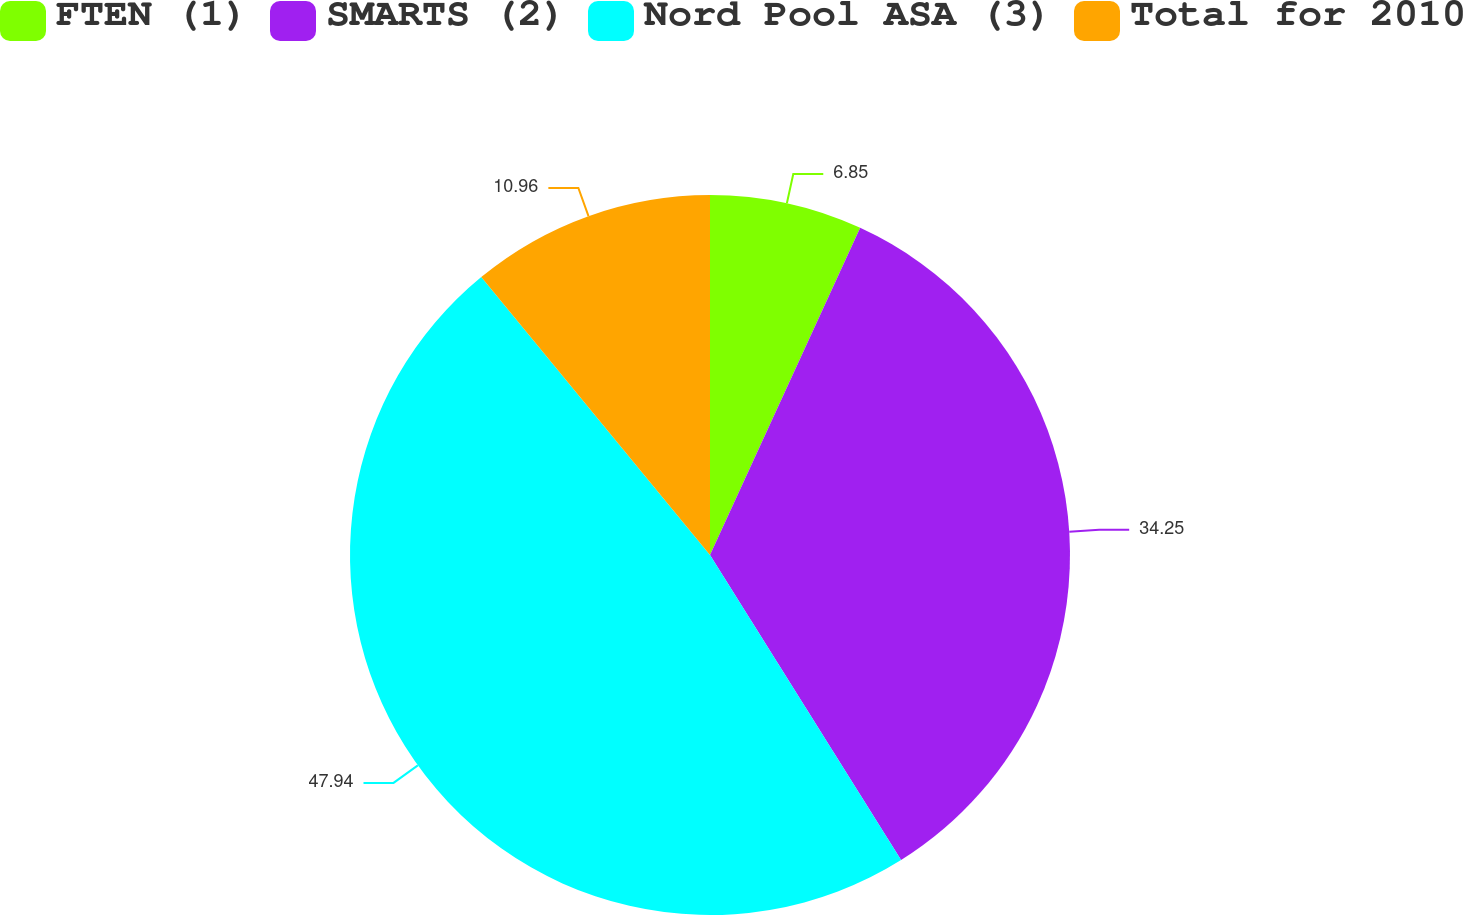Convert chart to OTSL. <chart><loc_0><loc_0><loc_500><loc_500><pie_chart><fcel>FTEN (1)<fcel>SMARTS (2)<fcel>Nord Pool ASA (3)<fcel>Total for 2010<nl><fcel>6.85%<fcel>34.25%<fcel>47.95%<fcel>10.96%<nl></chart> 